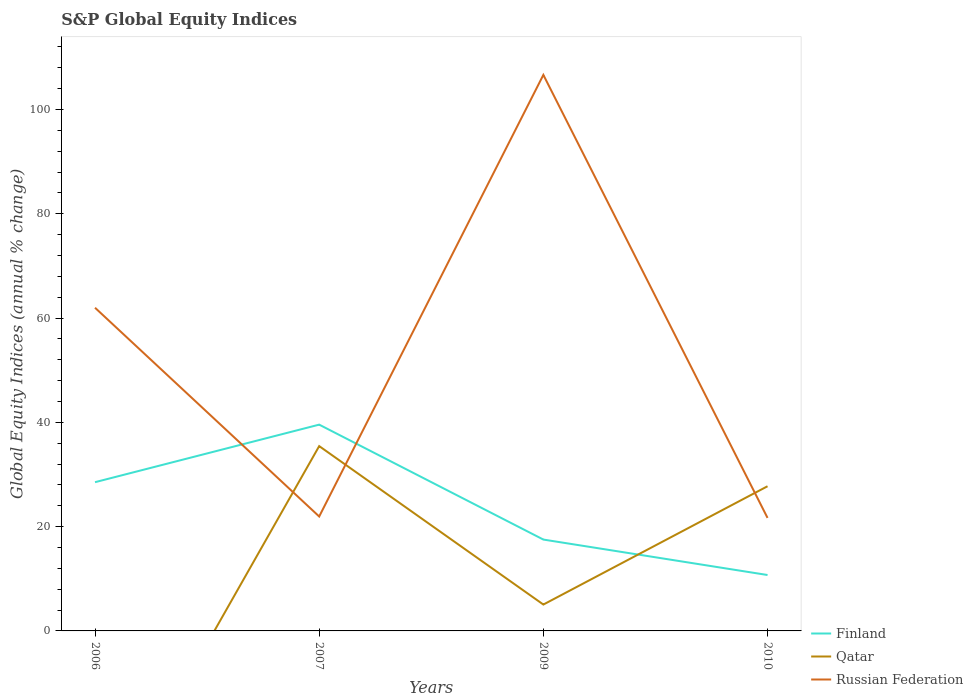How many different coloured lines are there?
Your response must be concise. 3. Does the line corresponding to Finland intersect with the line corresponding to Qatar?
Offer a very short reply. Yes. What is the total global equity indices in Russian Federation in the graph?
Offer a very short reply. 40.31. What is the difference between the highest and the second highest global equity indices in Finland?
Make the answer very short. 28.84. What is the difference between the highest and the lowest global equity indices in Qatar?
Offer a terse response. 2. How many lines are there?
Your response must be concise. 3. How many years are there in the graph?
Give a very brief answer. 4. What is the difference between two consecutive major ticks on the Y-axis?
Your answer should be compact. 20. Does the graph contain any zero values?
Keep it short and to the point. Yes. Where does the legend appear in the graph?
Your answer should be compact. Bottom right. How are the legend labels stacked?
Provide a short and direct response. Vertical. What is the title of the graph?
Provide a short and direct response. S&P Global Equity Indices. What is the label or title of the X-axis?
Provide a short and direct response. Years. What is the label or title of the Y-axis?
Your answer should be very brief. Global Equity Indices (annual % change). What is the Global Equity Indices (annual % change) of Finland in 2006?
Provide a short and direct response. 28.52. What is the Global Equity Indices (annual % change) in Russian Federation in 2006?
Make the answer very short. 61.98. What is the Global Equity Indices (annual % change) of Finland in 2007?
Offer a very short reply. 39.56. What is the Global Equity Indices (annual % change) in Qatar in 2007?
Give a very brief answer. 35.44. What is the Global Equity Indices (annual % change) in Russian Federation in 2007?
Ensure brevity in your answer.  21.94. What is the Global Equity Indices (annual % change) of Finland in 2009?
Make the answer very short. 17.52. What is the Global Equity Indices (annual % change) in Qatar in 2009?
Offer a terse response. 5.06. What is the Global Equity Indices (annual % change) in Russian Federation in 2009?
Ensure brevity in your answer.  106.63. What is the Global Equity Indices (annual % change) of Finland in 2010?
Provide a succinct answer. 10.72. What is the Global Equity Indices (annual % change) of Qatar in 2010?
Ensure brevity in your answer.  27.74. What is the Global Equity Indices (annual % change) of Russian Federation in 2010?
Your answer should be compact. 21.67. Across all years, what is the maximum Global Equity Indices (annual % change) in Finland?
Your response must be concise. 39.56. Across all years, what is the maximum Global Equity Indices (annual % change) in Qatar?
Offer a terse response. 35.44. Across all years, what is the maximum Global Equity Indices (annual % change) in Russian Federation?
Ensure brevity in your answer.  106.63. Across all years, what is the minimum Global Equity Indices (annual % change) in Finland?
Your answer should be compact. 10.72. Across all years, what is the minimum Global Equity Indices (annual % change) in Qatar?
Your answer should be compact. 0. Across all years, what is the minimum Global Equity Indices (annual % change) of Russian Federation?
Offer a terse response. 21.67. What is the total Global Equity Indices (annual % change) of Finland in the graph?
Your answer should be very brief. 96.32. What is the total Global Equity Indices (annual % change) in Qatar in the graph?
Give a very brief answer. 68.25. What is the total Global Equity Indices (annual % change) of Russian Federation in the graph?
Your answer should be compact. 212.23. What is the difference between the Global Equity Indices (annual % change) of Finland in 2006 and that in 2007?
Make the answer very short. -11.04. What is the difference between the Global Equity Indices (annual % change) in Russian Federation in 2006 and that in 2007?
Ensure brevity in your answer.  40.04. What is the difference between the Global Equity Indices (annual % change) in Finland in 2006 and that in 2009?
Offer a terse response. 11. What is the difference between the Global Equity Indices (annual % change) in Russian Federation in 2006 and that in 2009?
Keep it short and to the point. -44.65. What is the difference between the Global Equity Indices (annual % change) in Finland in 2006 and that in 2010?
Provide a succinct answer. 17.8. What is the difference between the Global Equity Indices (annual % change) of Russian Federation in 2006 and that in 2010?
Provide a short and direct response. 40.31. What is the difference between the Global Equity Indices (annual % change) of Finland in 2007 and that in 2009?
Keep it short and to the point. 22.04. What is the difference between the Global Equity Indices (annual % change) of Qatar in 2007 and that in 2009?
Offer a terse response. 30.39. What is the difference between the Global Equity Indices (annual % change) in Russian Federation in 2007 and that in 2009?
Offer a very short reply. -84.69. What is the difference between the Global Equity Indices (annual % change) in Finland in 2007 and that in 2010?
Offer a very short reply. 28.84. What is the difference between the Global Equity Indices (annual % change) in Qatar in 2007 and that in 2010?
Keep it short and to the point. 7.7. What is the difference between the Global Equity Indices (annual % change) in Russian Federation in 2007 and that in 2010?
Your answer should be very brief. 0.27. What is the difference between the Global Equity Indices (annual % change) in Finland in 2009 and that in 2010?
Ensure brevity in your answer.  6.8. What is the difference between the Global Equity Indices (annual % change) in Qatar in 2009 and that in 2010?
Provide a succinct answer. -22.69. What is the difference between the Global Equity Indices (annual % change) of Russian Federation in 2009 and that in 2010?
Give a very brief answer. 84.96. What is the difference between the Global Equity Indices (annual % change) of Finland in 2006 and the Global Equity Indices (annual % change) of Qatar in 2007?
Provide a succinct answer. -6.92. What is the difference between the Global Equity Indices (annual % change) of Finland in 2006 and the Global Equity Indices (annual % change) of Russian Federation in 2007?
Your response must be concise. 6.58. What is the difference between the Global Equity Indices (annual % change) in Finland in 2006 and the Global Equity Indices (annual % change) in Qatar in 2009?
Offer a very short reply. 23.46. What is the difference between the Global Equity Indices (annual % change) of Finland in 2006 and the Global Equity Indices (annual % change) of Russian Federation in 2009?
Offer a very short reply. -78.11. What is the difference between the Global Equity Indices (annual % change) in Finland in 2006 and the Global Equity Indices (annual % change) in Qatar in 2010?
Provide a short and direct response. 0.78. What is the difference between the Global Equity Indices (annual % change) of Finland in 2006 and the Global Equity Indices (annual % change) of Russian Federation in 2010?
Your response must be concise. 6.85. What is the difference between the Global Equity Indices (annual % change) in Finland in 2007 and the Global Equity Indices (annual % change) in Qatar in 2009?
Provide a short and direct response. 34.5. What is the difference between the Global Equity Indices (annual % change) of Finland in 2007 and the Global Equity Indices (annual % change) of Russian Federation in 2009?
Keep it short and to the point. -67.07. What is the difference between the Global Equity Indices (annual % change) in Qatar in 2007 and the Global Equity Indices (annual % change) in Russian Federation in 2009?
Give a very brief answer. -71.19. What is the difference between the Global Equity Indices (annual % change) of Finland in 2007 and the Global Equity Indices (annual % change) of Qatar in 2010?
Provide a short and direct response. 11.81. What is the difference between the Global Equity Indices (annual % change) of Finland in 2007 and the Global Equity Indices (annual % change) of Russian Federation in 2010?
Provide a succinct answer. 17.89. What is the difference between the Global Equity Indices (annual % change) of Qatar in 2007 and the Global Equity Indices (annual % change) of Russian Federation in 2010?
Offer a very short reply. 13.77. What is the difference between the Global Equity Indices (annual % change) in Finland in 2009 and the Global Equity Indices (annual % change) in Qatar in 2010?
Your answer should be very brief. -10.22. What is the difference between the Global Equity Indices (annual % change) in Finland in 2009 and the Global Equity Indices (annual % change) in Russian Federation in 2010?
Ensure brevity in your answer.  -4.15. What is the difference between the Global Equity Indices (annual % change) of Qatar in 2009 and the Global Equity Indices (annual % change) of Russian Federation in 2010?
Provide a short and direct response. -16.62. What is the average Global Equity Indices (annual % change) in Finland per year?
Keep it short and to the point. 24.08. What is the average Global Equity Indices (annual % change) in Qatar per year?
Provide a short and direct response. 17.06. What is the average Global Equity Indices (annual % change) of Russian Federation per year?
Offer a terse response. 53.06. In the year 2006, what is the difference between the Global Equity Indices (annual % change) in Finland and Global Equity Indices (annual % change) in Russian Federation?
Ensure brevity in your answer.  -33.46. In the year 2007, what is the difference between the Global Equity Indices (annual % change) of Finland and Global Equity Indices (annual % change) of Qatar?
Give a very brief answer. 4.12. In the year 2007, what is the difference between the Global Equity Indices (annual % change) of Finland and Global Equity Indices (annual % change) of Russian Federation?
Your answer should be very brief. 17.62. In the year 2007, what is the difference between the Global Equity Indices (annual % change) in Qatar and Global Equity Indices (annual % change) in Russian Federation?
Your response must be concise. 13.5. In the year 2009, what is the difference between the Global Equity Indices (annual % change) of Finland and Global Equity Indices (annual % change) of Qatar?
Provide a short and direct response. 12.46. In the year 2009, what is the difference between the Global Equity Indices (annual % change) of Finland and Global Equity Indices (annual % change) of Russian Federation?
Provide a succinct answer. -89.11. In the year 2009, what is the difference between the Global Equity Indices (annual % change) in Qatar and Global Equity Indices (annual % change) in Russian Federation?
Offer a terse response. -101.57. In the year 2010, what is the difference between the Global Equity Indices (annual % change) of Finland and Global Equity Indices (annual % change) of Qatar?
Your answer should be very brief. -17.02. In the year 2010, what is the difference between the Global Equity Indices (annual % change) of Finland and Global Equity Indices (annual % change) of Russian Federation?
Keep it short and to the point. -10.95. In the year 2010, what is the difference between the Global Equity Indices (annual % change) in Qatar and Global Equity Indices (annual % change) in Russian Federation?
Offer a terse response. 6.07. What is the ratio of the Global Equity Indices (annual % change) in Finland in 2006 to that in 2007?
Your answer should be very brief. 0.72. What is the ratio of the Global Equity Indices (annual % change) in Russian Federation in 2006 to that in 2007?
Your response must be concise. 2.82. What is the ratio of the Global Equity Indices (annual % change) of Finland in 2006 to that in 2009?
Your response must be concise. 1.63. What is the ratio of the Global Equity Indices (annual % change) in Russian Federation in 2006 to that in 2009?
Make the answer very short. 0.58. What is the ratio of the Global Equity Indices (annual % change) of Finland in 2006 to that in 2010?
Make the answer very short. 2.66. What is the ratio of the Global Equity Indices (annual % change) of Russian Federation in 2006 to that in 2010?
Your answer should be compact. 2.86. What is the ratio of the Global Equity Indices (annual % change) in Finland in 2007 to that in 2009?
Your answer should be very brief. 2.26. What is the ratio of the Global Equity Indices (annual % change) in Qatar in 2007 to that in 2009?
Your response must be concise. 7.01. What is the ratio of the Global Equity Indices (annual % change) in Russian Federation in 2007 to that in 2009?
Provide a short and direct response. 0.21. What is the ratio of the Global Equity Indices (annual % change) of Finland in 2007 to that in 2010?
Your answer should be compact. 3.69. What is the ratio of the Global Equity Indices (annual % change) of Qatar in 2007 to that in 2010?
Offer a very short reply. 1.28. What is the ratio of the Global Equity Indices (annual % change) of Russian Federation in 2007 to that in 2010?
Ensure brevity in your answer.  1.01. What is the ratio of the Global Equity Indices (annual % change) in Finland in 2009 to that in 2010?
Offer a very short reply. 1.63. What is the ratio of the Global Equity Indices (annual % change) in Qatar in 2009 to that in 2010?
Ensure brevity in your answer.  0.18. What is the ratio of the Global Equity Indices (annual % change) in Russian Federation in 2009 to that in 2010?
Offer a terse response. 4.92. What is the difference between the highest and the second highest Global Equity Indices (annual % change) of Finland?
Offer a terse response. 11.04. What is the difference between the highest and the second highest Global Equity Indices (annual % change) of Qatar?
Your answer should be very brief. 7.7. What is the difference between the highest and the second highest Global Equity Indices (annual % change) in Russian Federation?
Your answer should be very brief. 44.65. What is the difference between the highest and the lowest Global Equity Indices (annual % change) of Finland?
Keep it short and to the point. 28.84. What is the difference between the highest and the lowest Global Equity Indices (annual % change) in Qatar?
Offer a terse response. 35.44. What is the difference between the highest and the lowest Global Equity Indices (annual % change) of Russian Federation?
Your response must be concise. 84.96. 